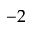Convert formula to latex. <formula><loc_0><loc_0><loc_500><loc_500>- 2</formula> 